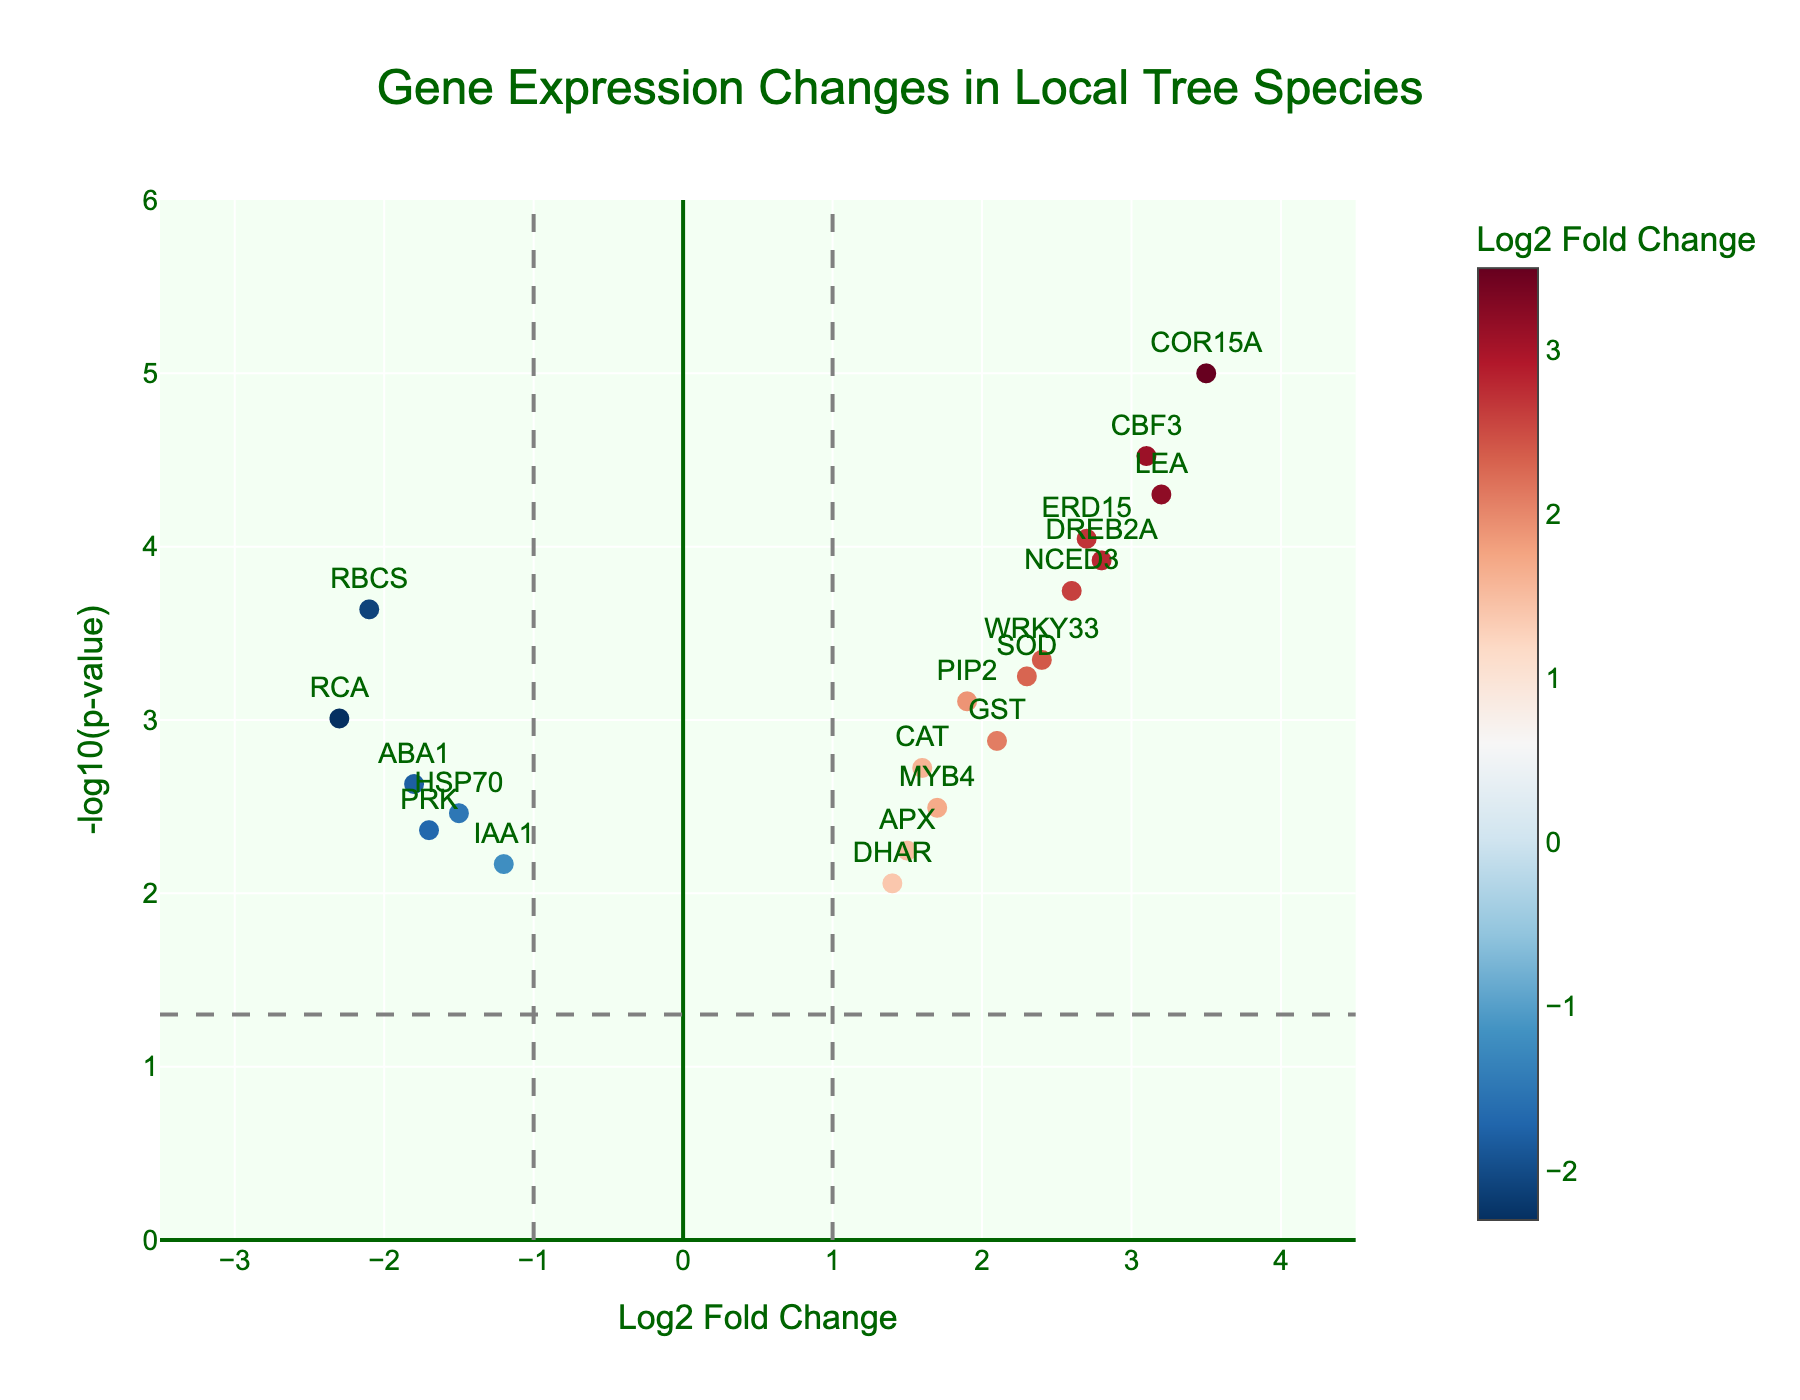How many genes are shown in the figure? Count the number of unique gene names labeled in the figure.
Answer: 19 What's the title of the figure? The title of the figure can usually be found at the top center of the plot.
Answer: Gene Expression Changes in Local Tree Species Which gene has the highest Log2 Fold Change and what's its value? Find the gene name labeled at the highest x-axis position (most right on the horizontal axis).
Answer: COR15A, 3.5 Which gene has the lowest Log2 Fold Change and what's its value? Find the gene name labeled at the lowest x-axis position (most left on the horizontal axis).
Answer: RCA, -2.3 What does the horizontal dashed line represent in the plot? Look for the threshold line along the y-axis and interpret the commonly used cut-off for p-values in a Volcano Plot, which is -log10(0.05).
Answer: p-value threshold What does it mean if a gene is positioned to the far right of the plot? Genes positioned to the far right have high positive Log2 Fold Change values, indicating they are upregulated.
Answer: Upregulated How many genes are upregulated with a Log2 Fold Change greater than 2? Count the number of genes that have a Log2 Fold Change value greater than 2.
Answer: 8 Among the upregulated genes, which one has the highest -log10(p-value) and what's its value? Find the highest point in the positive Log2 Fold Change region and identify the corresponding -log10(p-value).
Answer: COR15A, 5 Compare DREB2A and MYB4 in terms of Log2 Fold Change and p-value. Which gene is more upregulated and statistically significant? Inspect the positions of both genes on the x-axis and y-axis. DREB2A is further to the right (2.8 vs 1.7) and higher on the y-axis (more significant p-value).
Answer: DREB2A How many genes are significantly downregulated (Log2 Fold Change less than -1 and p-value less than 0.05)? Count the genes in the negative Log2 Fold Change region with -log10(p-value) above the dashed line.
Answer: 4 